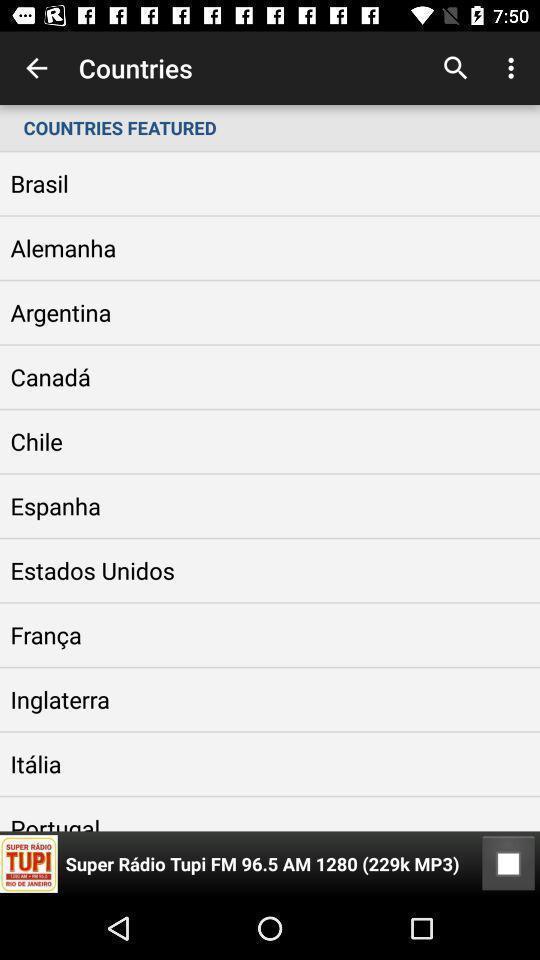Give me a narrative description of this picture. Page showing a list of countries. 